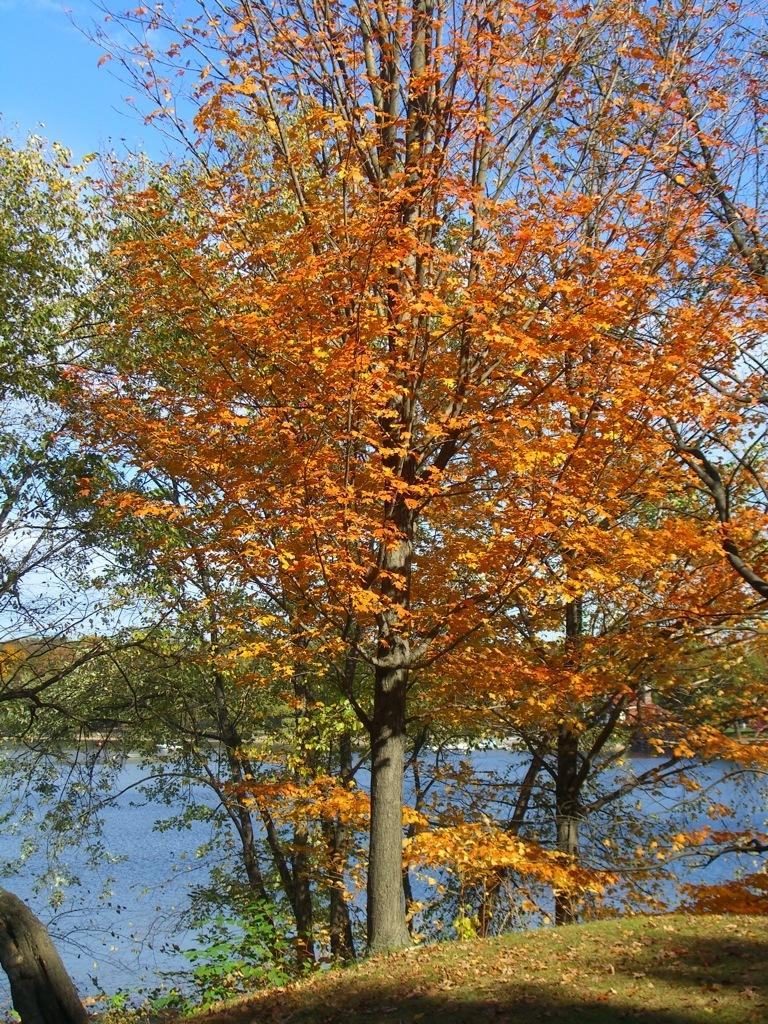What is located in the center of the image? There are trees in the center of the image. What can be seen in the background of the image? There is a lake, hills, and the sky visible in the background. What type of vegetation is at the bottom of the image? There is grass at the bottom of the image. What shape is the water pump in the image? There is no water pump present in the image. How does the water move in the image? There is no water present in the image, so it cannot move. 